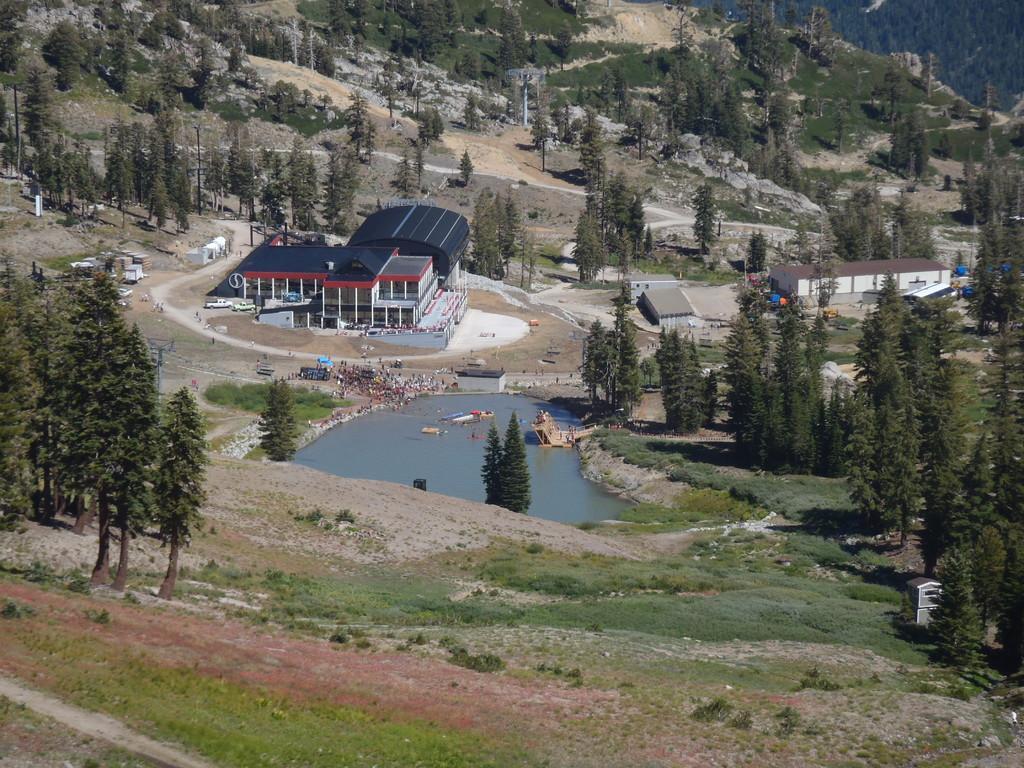Could you give a brief overview of what you see in this image? This image consists of a building. At the bottom, there is water and green grass on the ground. And we can see many trees in this image. 